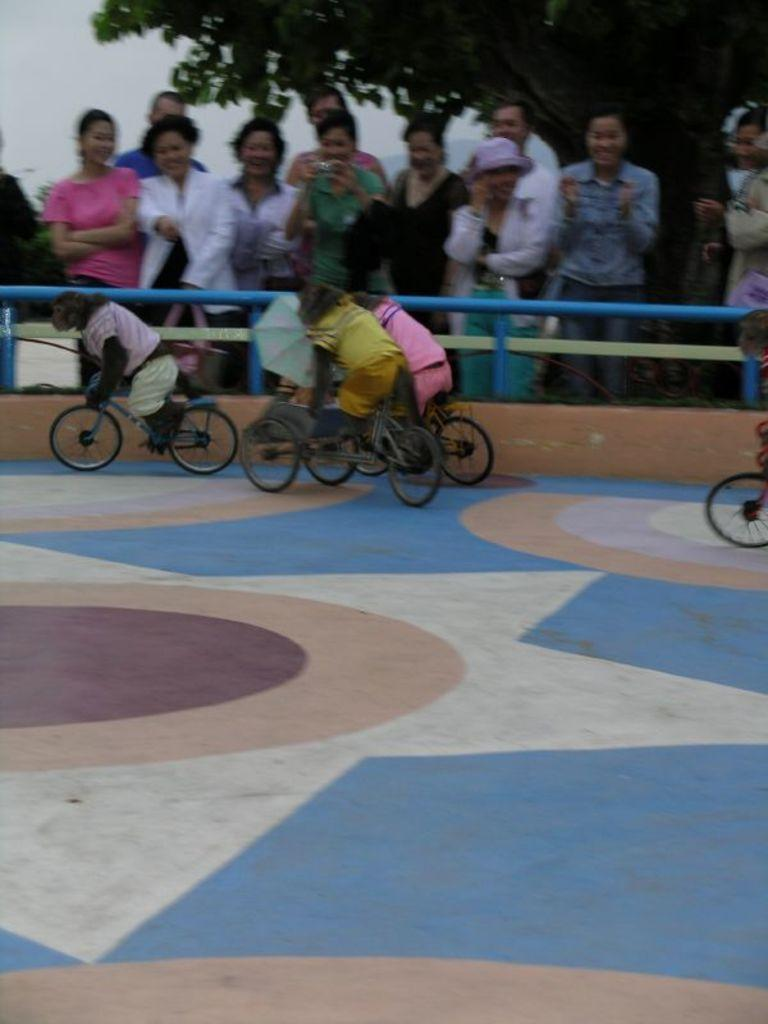What animals are featured in the image? There are monkeys in the image. What are the monkeys doing in the image? The monkeys are riding bicycles. What can be seen in the background of the image? There are people and a tree in the background of the image. What is visible at the bottom of the image? There is a floor visible at the bottom of the image. What type of boot can be seen hanging from the tree in the image? There is no boot present in the image; it features monkeys riding bicycles with a tree and people in the background. 